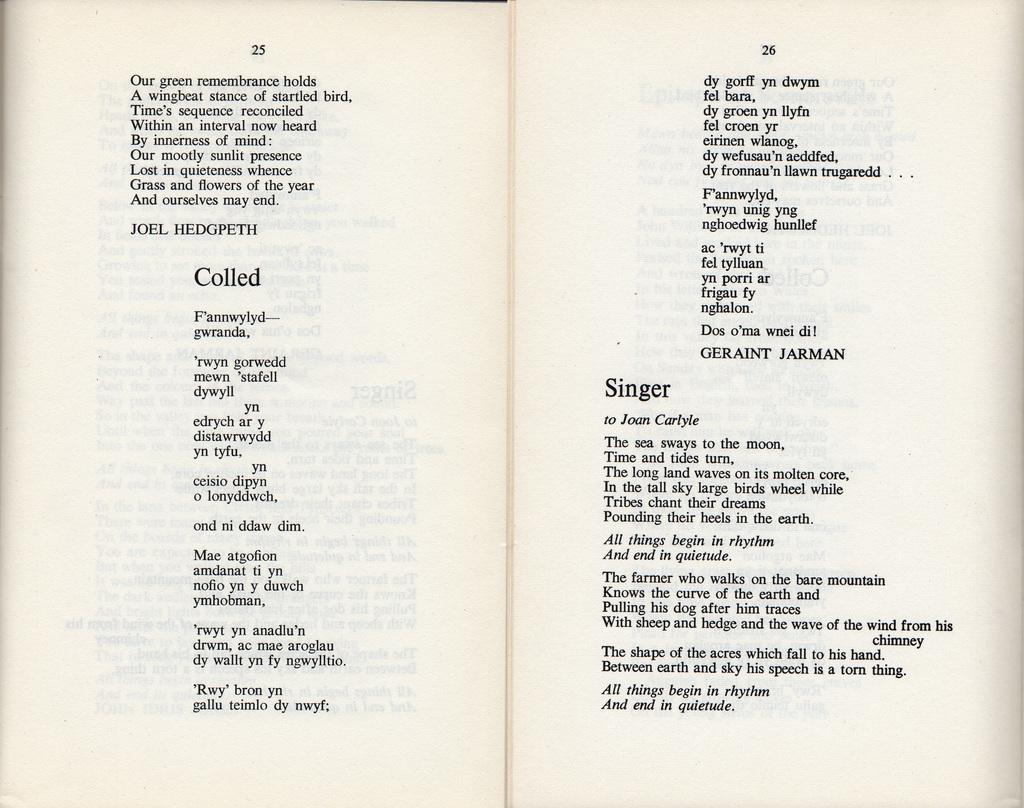What pages did the reader stop on?
Offer a very short reply. 25 and 26. What is the title on the middle of the page on the right?
Provide a short and direct response. Singer. 